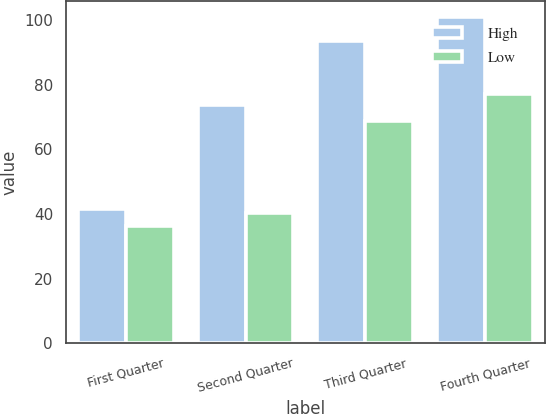<chart> <loc_0><loc_0><loc_500><loc_500><stacked_bar_chart><ecel><fcel>First Quarter<fcel>Second Quarter<fcel>Third Quarter<fcel>Fourth Quarter<nl><fcel>High<fcel>41.51<fcel>73.65<fcel>93.48<fcel>100.82<nl><fcel>Low<fcel>36.43<fcel>40.42<fcel>68.73<fcel>77<nl></chart> 